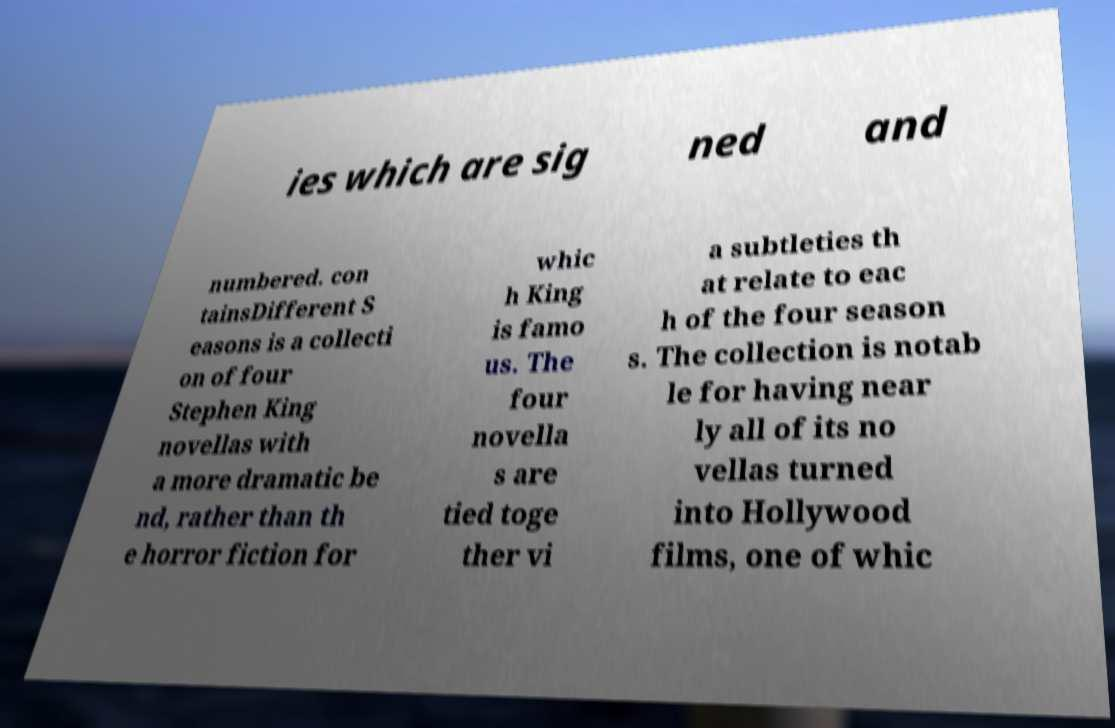Can you read and provide the text displayed in the image?This photo seems to have some interesting text. Can you extract and type it out for me? ies which are sig ned and numbered. con tainsDifferent S easons is a collecti on of four Stephen King novellas with a more dramatic be nd, rather than th e horror fiction for whic h King is famo us. The four novella s are tied toge ther vi a subtleties th at relate to eac h of the four season s. The collection is notab le for having near ly all of its no vellas turned into Hollywood films, one of whic 